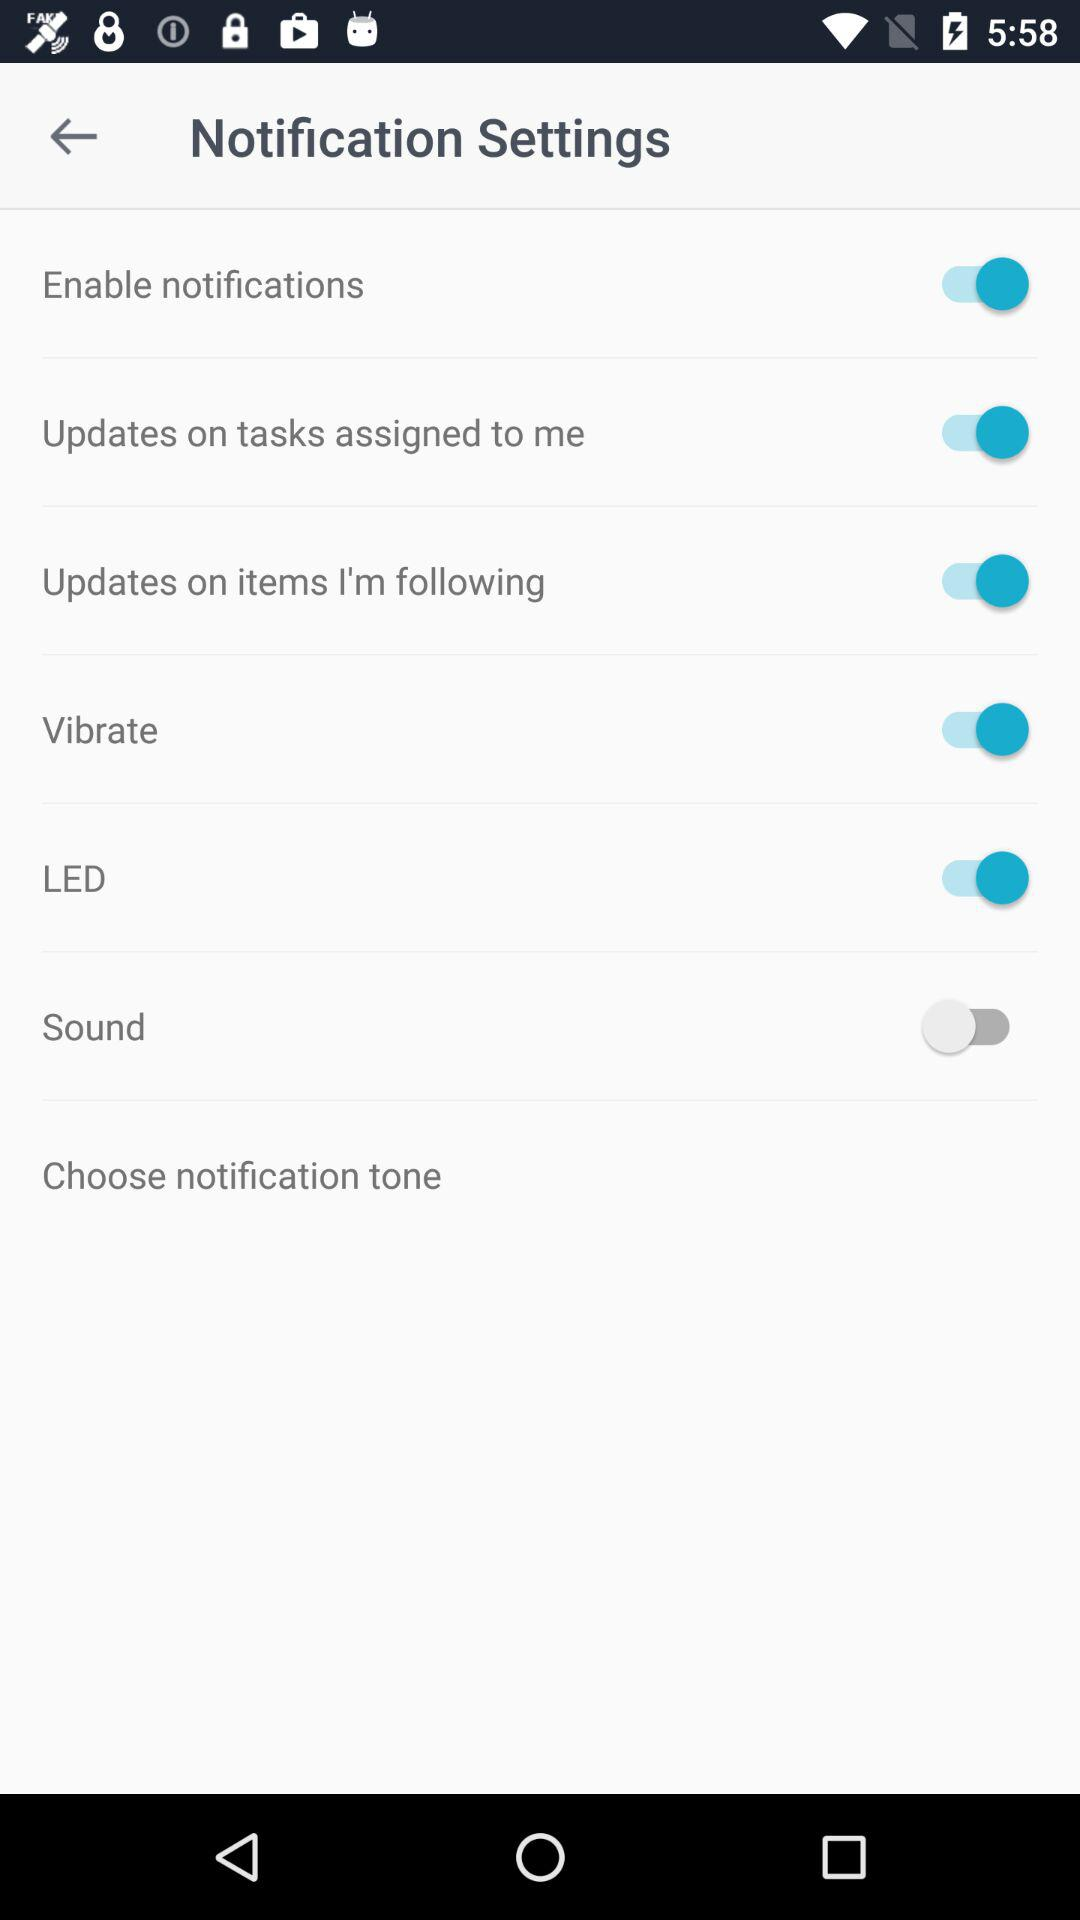How many items can be customized?
Answer the question using a single word or phrase. 6 